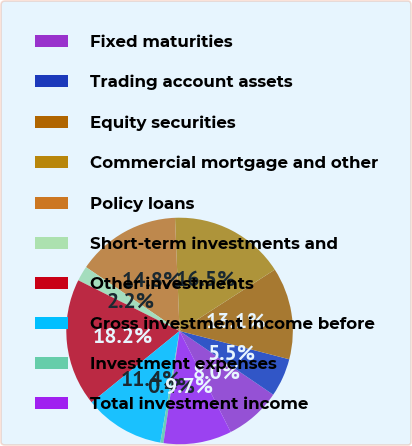Convert chart to OTSL. <chart><loc_0><loc_0><loc_500><loc_500><pie_chart><fcel>Fixed maturities<fcel>Trading account assets<fcel>Equity securities<fcel>Commercial mortgage and other<fcel>Policy loans<fcel>Short-term investments and<fcel>Other investments<fcel>Gross investment income before<fcel>Investment expenses<fcel>Total investment income<nl><fcel>8.03%<fcel>5.49%<fcel>13.13%<fcel>16.53%<fcel>14.83%<fcel>2.15%<fcel>18.23%<fcel>11.43%<fcel>0.45%<fcel>9.73%<nl></chart> 